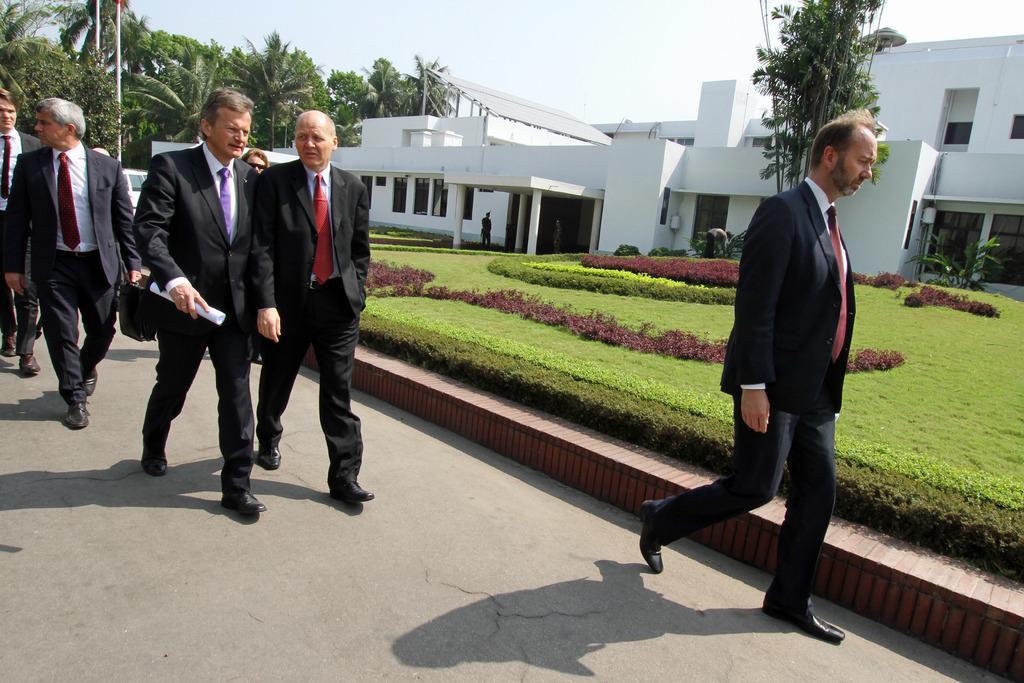Please provide a concise description of this image. In the image there are few men with black jacket is standing on the road. Behind them there is a garden with grass, green and maroon color small bushes. In the background there is a building with white walls, windows, pillars and roofs. And also there are trees in the background. 